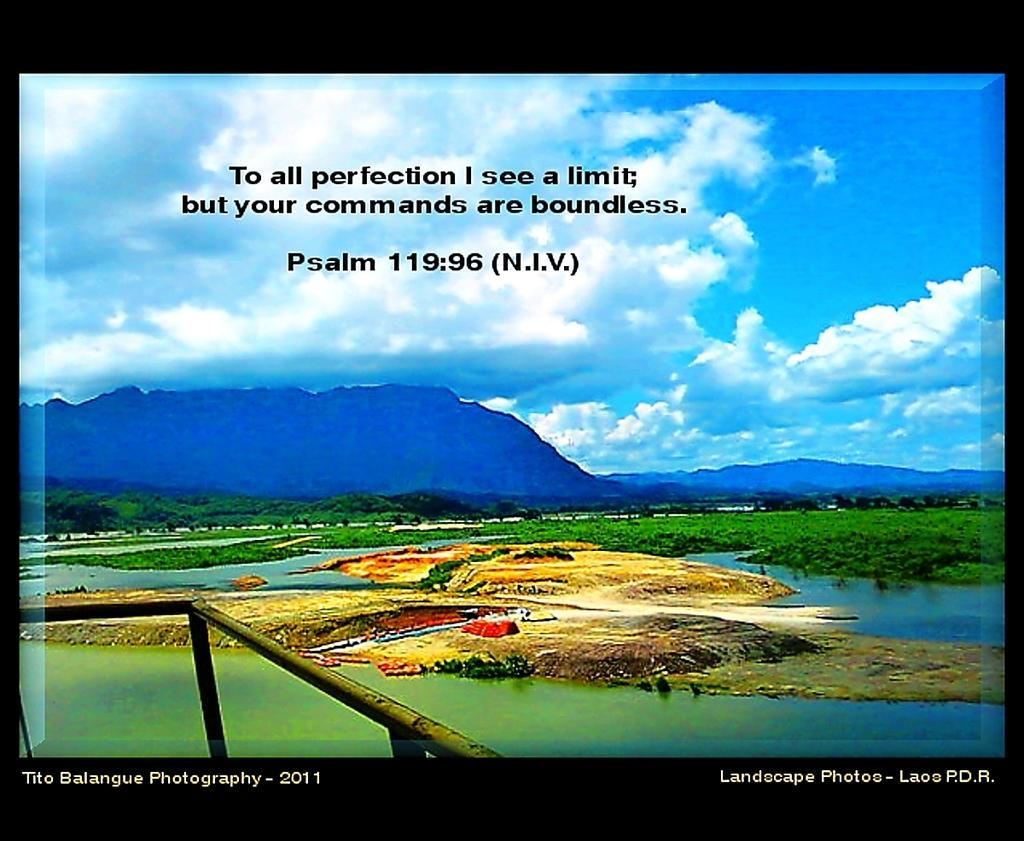<image>
Offer a succinct explanation of the picture presented. The words of a psalm are written over a colorful nature image. 